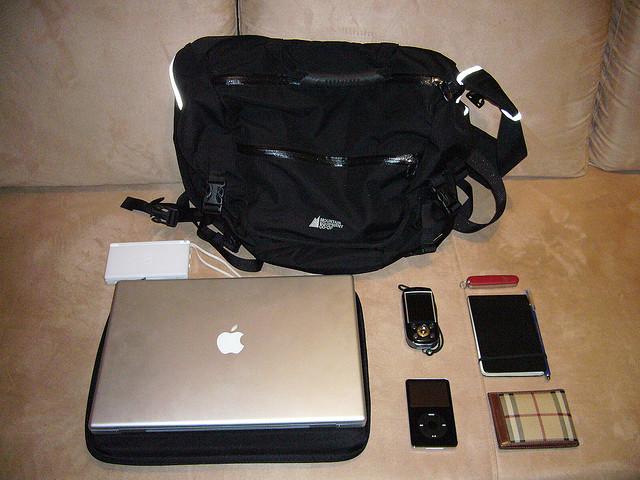Is that an iPod or iPhone?
Keep it brief. Ipod. Where are the suitcases?
Quick response, please. Couch. Where is the tote bag?
Answer briefly. Couch. What bag symbolize and what it says?
Quick response, please. North face. What symbol is on the laptop?
Write a very short answer. Apple. What color is the tag on the left side of the silver suitcase?
Concise answer only. White. 